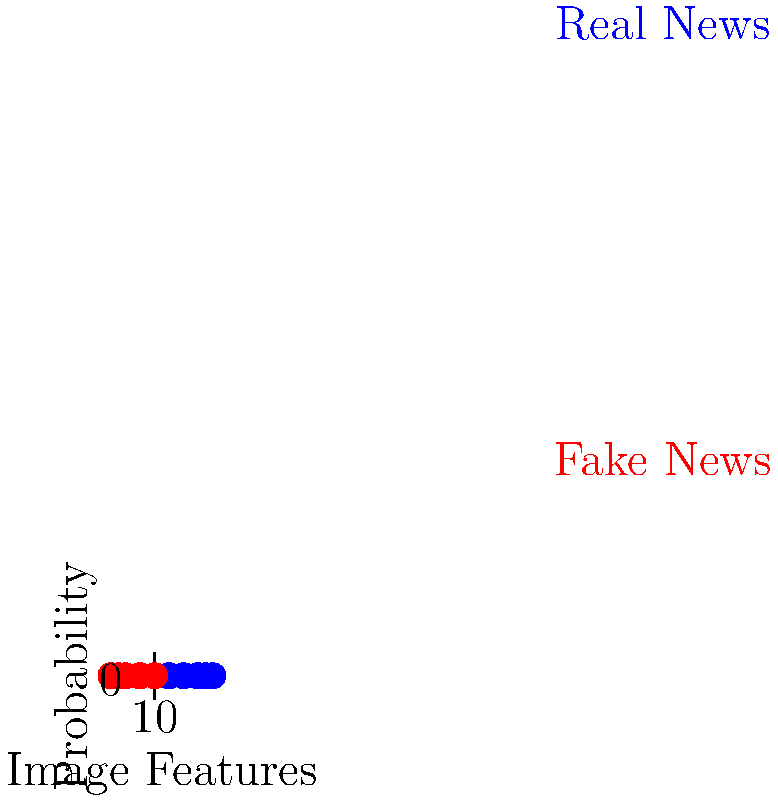Based on the graph showing the probability of real and fake news across different image features, which machine learning technique would be most suitable for classifying social media posts as real or fake news? To determine the most suitable machine learning technique for classifying social media posts as real or fake news based on image features, let's analyze the graph and consider the problem:

1. Data representation: The graph shows two distinct classes (real news and fake news) plotted against various image features.

2. Separation: There's a clear separation between the two classes, with real news consistently having higher probabilities across different image features.

3. Non-linearity: The relationship between image features and probabilities doesn't appear to be strictly linear.

4. Binary classification: We're dealing with a binary classification problem (real vs. fake news).

5. Feature importance: Different image features seem to have varying levels of importance in distinguishing between real and fake news.

Considering these factors, a Support Vector Machine (SVM) with a non-linear kernel would be an excellent choice for this classification task:

- SVMs are well-suited for binary classification problems.
- They can handle non-linear decision boundaries using kernel tricks (e.g., RBF kernel).
- SVMs are effective when there's a clear margin of separation between classes.
- They perform well with high-dimensional data, which is likely the case with image features.
- SVMs can identify the most relevant features for classification.

While other techniques like Random Forests or Neural Networks could also be effective, SVMs offer a good balance of performance and interpretability for this specific problem.
Answer: Support Vector Machine (SVM) with non-linear kernel 